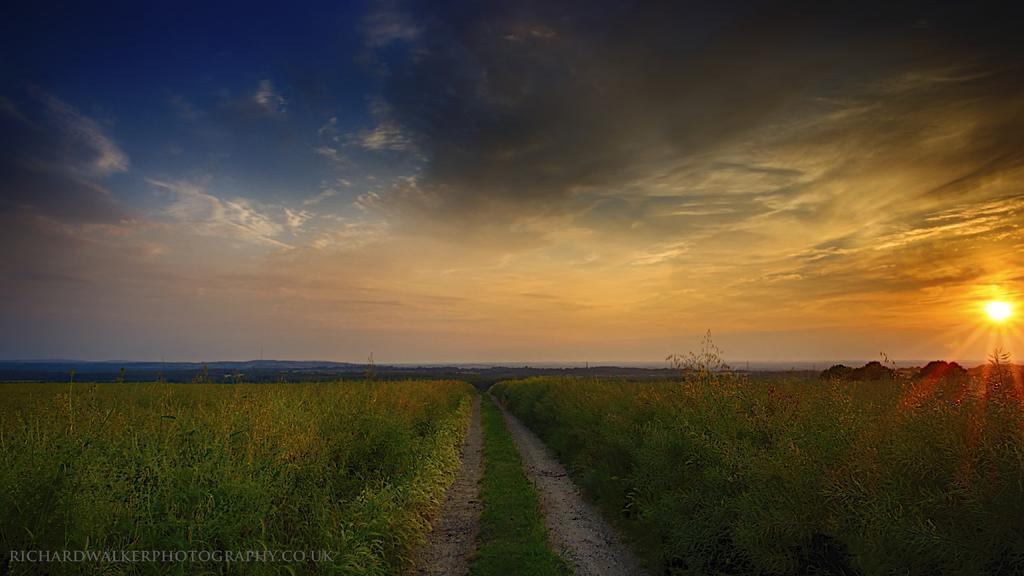How would you summarize this image in a sentence or two? As we can see in the image there are plants, sun, sky and clouds. 